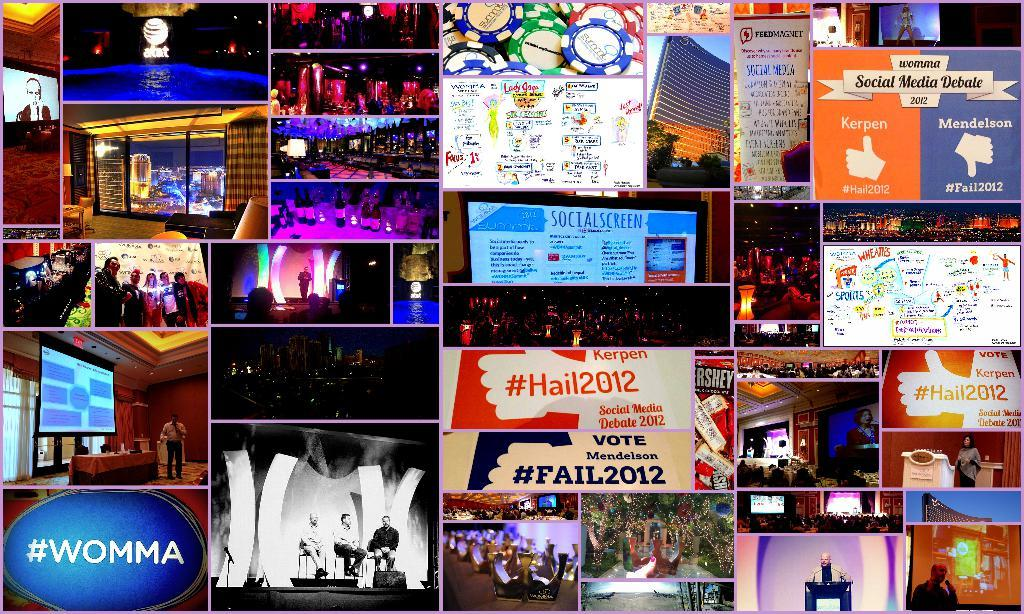Provide a one-sentence caption for the provided image. Blue sign in the bottom left reads #WOMMA. 